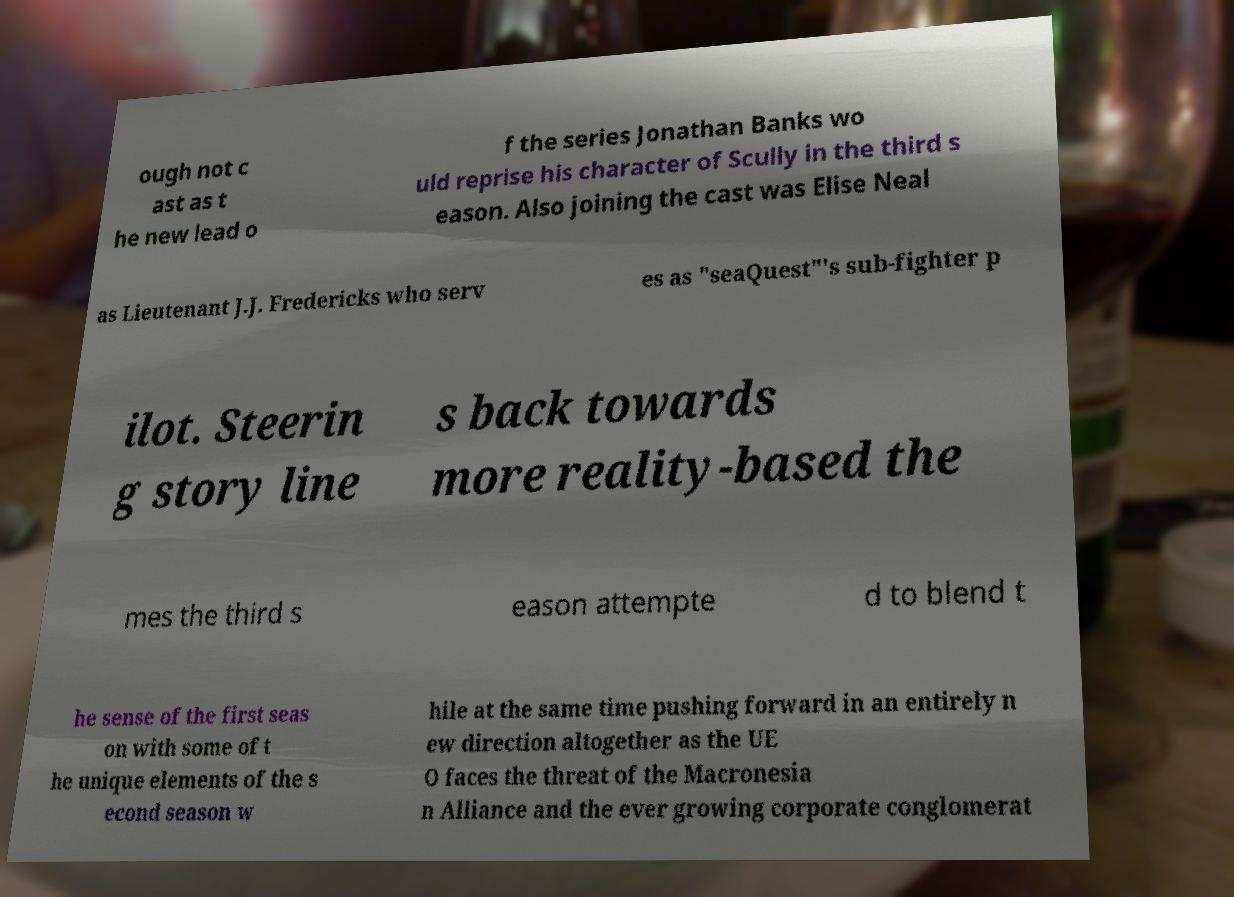What messages or text are displayed in this image? I need them in a readable, typed format. ough not c ast as t he new lead o f the series Jonathan Banks wo uld reprise his character of Scully in the third s eason. Also joining the cast was Elise Neal as Lieutenant J.J. Fredericks who serv es as "seaQuest"'s sub-fighter p ilot. Steerin g story line s back towards more reality-based the mes the third s eason attempte d to blend t he sense of the first seas on with some of t he unique elements of the s econd season w hile at the same time pushing forward in an entirely n ew direction altogether as the UE O faces the threat of the Macronesia n Alliance and the ever growing corporate conglomerat 